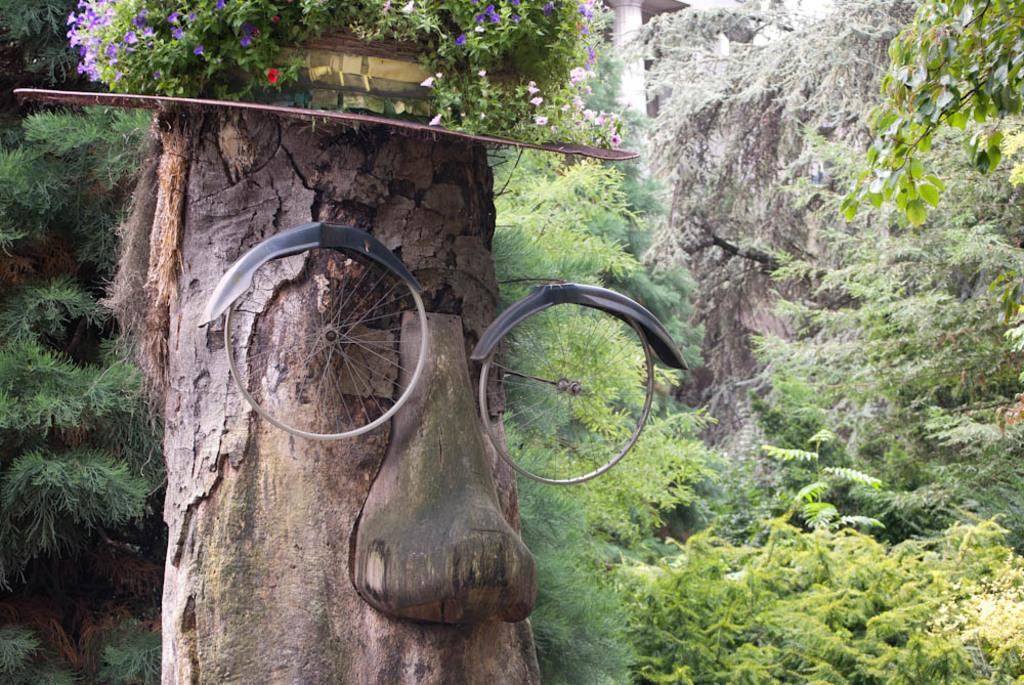What is unique about the tree trunk in the image? The tree trunk in the image has wheels. What is the purpose of the sheet in the image? The purpose of the sheet is not specified, but it is present in the image. What type of plants can be seen in the image? There are plants with flowers in the image. What can be seen in the background of the image? There are trees and a pillar in the background of the image. How many rings are visible on the tree trunk in the image? There are no rings visible on the tree trunk in the image, as it has wheels instead. 